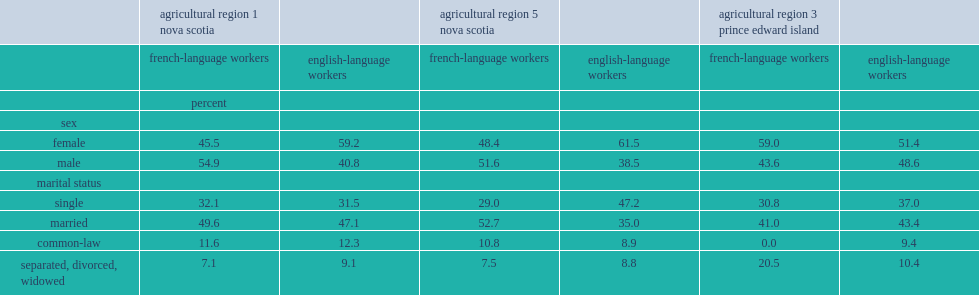Which sector of workers in nova scotia's agricultural regions had a higher proportion of male workers? french-language workforce or english-language workforce? French-language workers. What proportion of french-language workers was female in prince edward island's agricultural region 3? 59. Which sector of workers in prince edward island's agricultural region 3 had a higher percentage of female workers? french-language workers or english-language workers? French-language workers. Which sector of workers was less likely to be single in nova scotia's agricultural region 5 and prince edward island's agricultural region 3? french-language workers or english-language workers? French-language workers. Which sector of workers in nova scotia's agricultural region 5 was more likely to be married? french-language workers or english-language workers? French-language workers. Which sector of workers in prince edward island's agricultural region 3 was more likely than english-language workers to be separated, divorced, or widowed?french-language workers or english-language workers? French-language workers. 